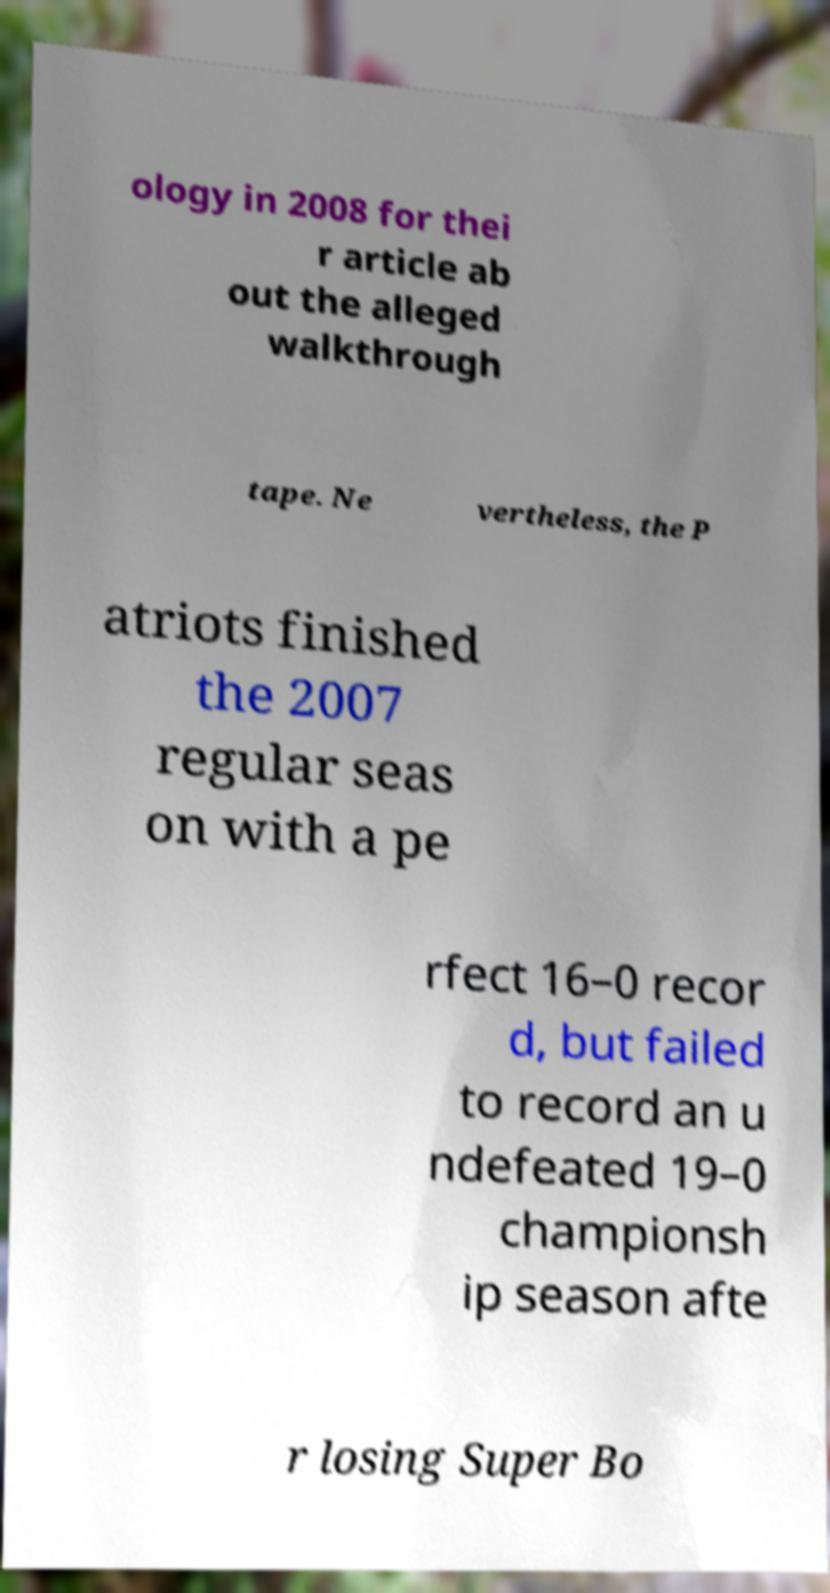Please read and relay the text visible in this image. What does it say? ology in 2008 for thei r article ab out the alleged walkthrough tape. Ne vertheless, the P atriots finished the 2007 regular seas on with a pe rfect 16–0 recor d, but failed to record an u ndefeated 19–0 championsh ip season afte r losing Super Bo 